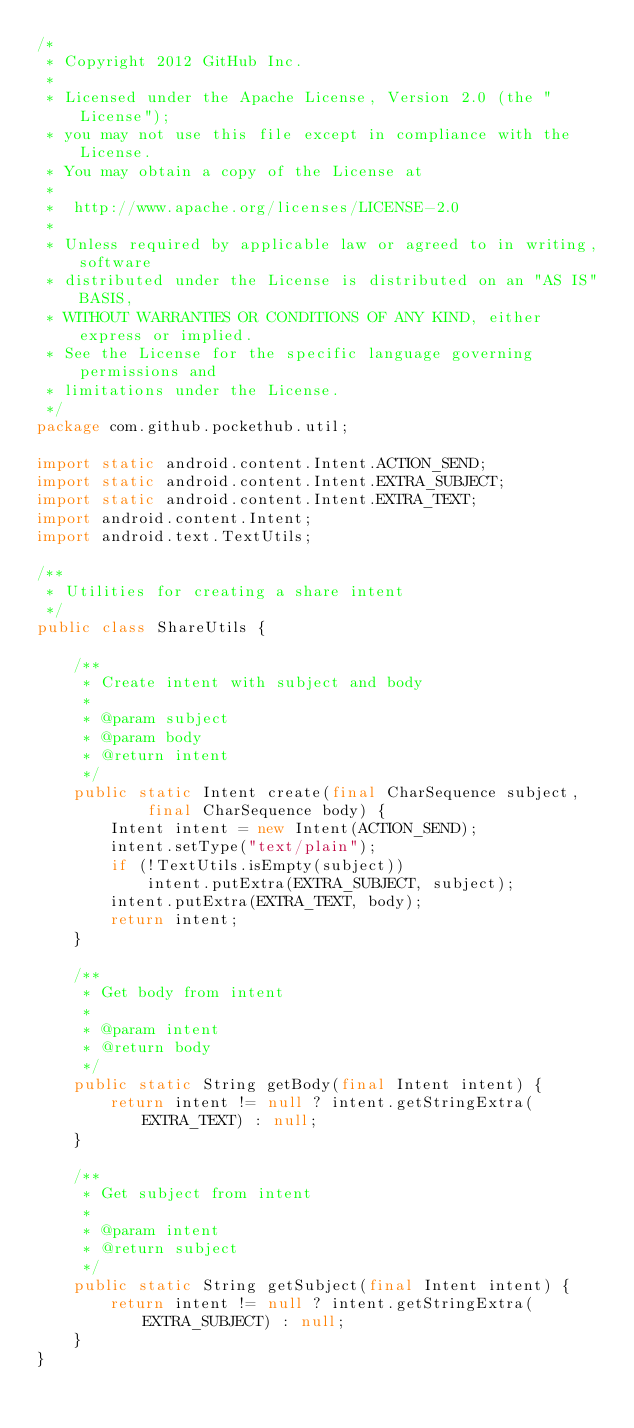Convert code to text. <code><loc_0><loc_0><loc_500><loc_500><_Java_>/*
 * Copyright 2012 GitHub Inc.
 *
 * Licensed under the Apache License, Version 2.0 (the "License");
 * you may not use this file except in compliance with the License.
 * You may obtain a copy of the License at
 *
 *  http://www.apache.org/licenses/LICENSE-2.0
 *
 * Unless required by applicable law or agreed to in writing, software
 * distributed under the License is distributed on an "AS IS" BASIS,
 * WITHOUT WARRANTIES OR CONDITIONS OF ANY KIND, either express or implied.
 * See the License for the specific language governing permissions and
 * limitations under the License.
 */
package com.github.pockethub.util;

import static android.content.Intent.ACTION_SEND;
import static android.content.Intent.EXTRA_SUBJECT;
import static android.content.Intent.EXTRA_TEXT;
import android.content.Intent;
import android.text.TextUtils;

/**
 * Utilities for creating a share intent
 */
public class ShareUtils {

    /**
     * Create intent with subject and body
     *
     * @param subject
     * @param body
     * @return intent
     */
    public static Intent create(final CharSequence subject,
            final CharSequence body) {
        Intent intent = new Intent(ACTION_SEND);
        intent.setType("text/plain");
        if (!TextUtils.isEmpty(subject))
            intent.putExtra(EXTRA_SUBJECT, subject);
        intent.putExtra(EXTRA_TEXT, body);
        return intent;
    }

    /**
     * Get body from intent
     *
     * @param intent
     * @return body
     */
    public static String getBody(final Intent intent) {
        return intent != null ? intent.getStringExtra(EXTRA_TEXT) : null;
    }

    /**
     * Get subject from intent
     *
     * @param intent
     * @return subject
     */
    public static String getSubject(final Intent intent) {
        return intent != null ? intent.getStringExtra(EXTRA_SUBJECT) : null;
    }
}
</code> 